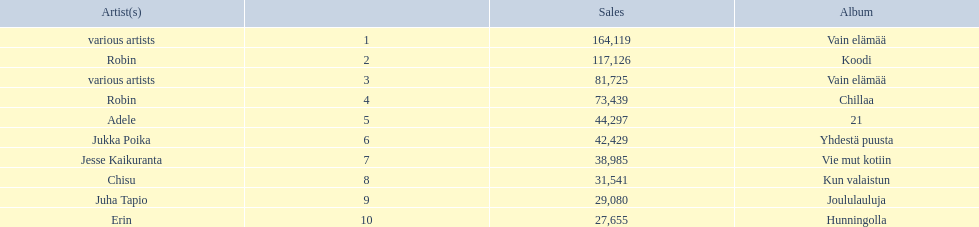Can you give me this table in json format? {'header': ['Artist(s)', '', 'Sales', 'Album'], 'rows': [['various artists', '1', '164,119', 'Vain elämää'], ['Robin', '2', '117,126', 'Koodi'], ['various artists', '3', '81,725', 'Vain elämää'], ['Robin', '4', '73,439', 'Chillaa'], ['Adele', '5', '44,297', '21'], ['Jukka Poika', '6', '42,429', 'Yhdestä puusta'], ['Jesse Kaikuranta', '7', '38,985', 'Vie mut kotiin'], ['Chisu', '8', '31,541', 'Kun valaistun'], ['Juha Tapio', '9', '29,080', 'Joululauluja'], ['Erin', '10', '27,655', 'Hunningolla']]} Which were the number-one albums of 2012 in finland? Vain elämää, Koodi, Vain elämää, Chillaa, 21, Yhdestä puusta, Vie mut kotiin, Kun valaistun, Joululauluja, Hunningolla. Of those albums, which were by robin? Koodi, Chillaa. Of those albums by robin, which is not chillaa? Koodi. 